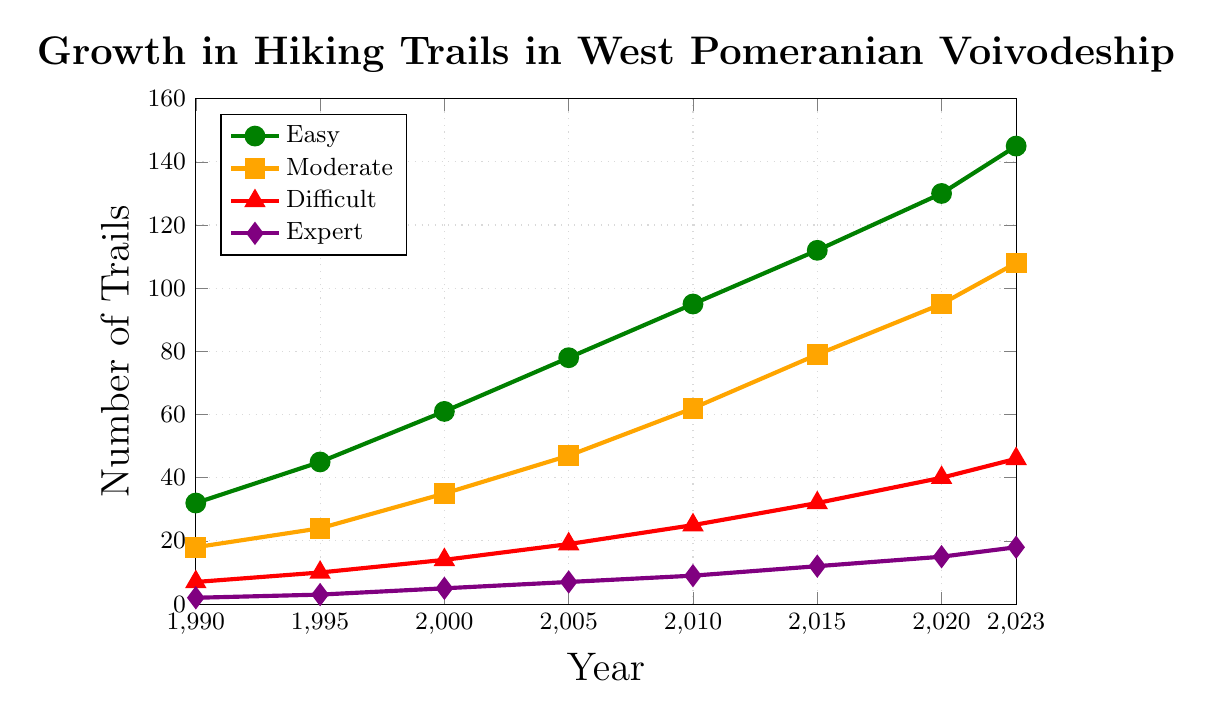Which difficulty level has seen the largest increase in the number of trails from 1990 to 2023? Calculate the increase for each difficulty level by subtracting the number of trails in 1990 from the number in 2023: Easy: 145 - 32 = 113, Moderate: 108 - 18 = 90, Difficult: 46 - 7 = 39, Expert: 18 - 2 = 16. The largest increase is for Easy trails.
Answer: Easy In which year did the number of Difficult trails exceed 25 for the first time? Review the number of Difficult trails over the years and identify the first instance where it exceeds 25. In 2010, there are 25 Difficult trails, and in 2015, there are 32, so it first exceeds 25 in 2015.
Answer: 2015 How many more Easy trails were there compared to Expert trails in 2023? Subtract the number of Expert trails from the number of Easy trails in 2023. Easy: 145, Expert: 18, so the difference is 145 - 18.
Answer: 127 Which difficulty level had the slowest rate of growth between 1990 and 2023? Calculate the increase for each difficulty level and compare them. Easy: 113, Moderate: 90, Difficult: 39, Expert: 16. The slowest growth is in Expert trails.
Answer: Expert What is the average number of Moderate trails from 1990 to 2023? Add the number of Moderate trails for all years and divide by the number of years. Moderate trails: 18, 24, 35, 47, 62, 79, 95, 108. Total = 468, years = 8, so the average is 468 / 8.
Answer: 58.5 Which year saw the highest year-over-year increase in the number of Easy trails? Calculate the year-over-year difference for Easy trails: 1995-1990: 13, 2000-1995: 16, 2005-2000: 17, 2010-2005: 17, 2015-2010: 17, 2020-2015: 18, 2023-2020: 15. The highest increase is 18 (2015 to 2020).
Answer: 2015-2020 What is the ratio of the number of Moderate trails to Difficult trails in 2005? Divide the number of Moderate trails by the number of Difficult trails in 2005. Moderate: 47, Difficult: 19, so the ratio is 47 / 19.
Answer: 2.47 Between which consecutive years did the number of Expert trails increase the least? Calculate the year-over-year difference for Expert trails: 1995-1990: 1, 2000-1995: 2, 2005-2000: 2, 2010-2005: 2, 2015-2010: 3, 2020-2015: 3, 2023-2020: 3. The smallest increase is 1, occurring between 1990 and 1995.
Answer: 1990-1995 